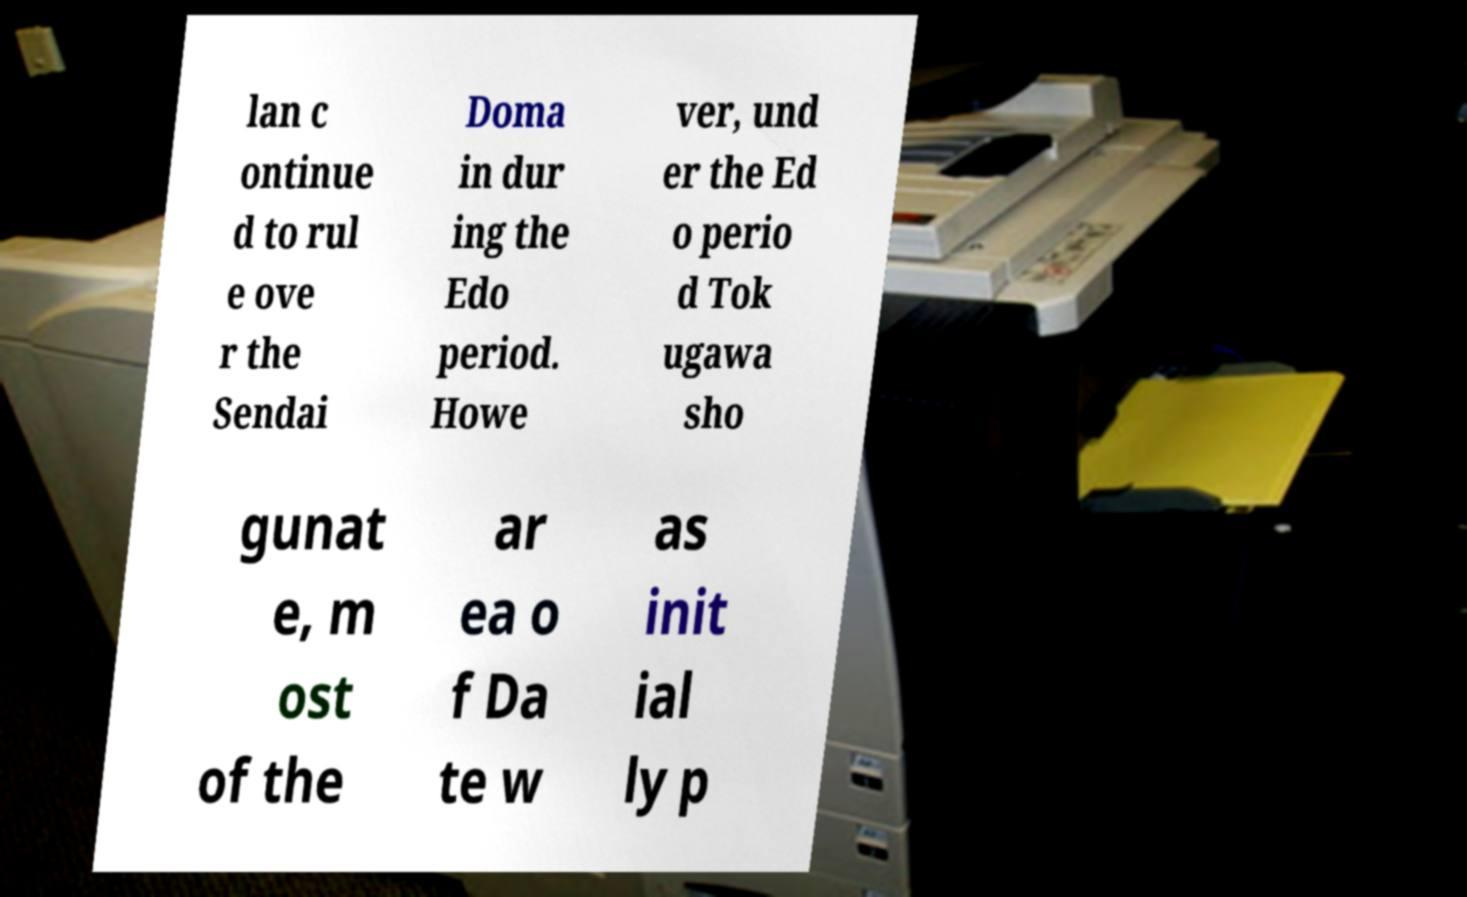There's text embedded in this image that I need extracted. Can you transcribe it verbatim? lan c ontinue d to rul e ove r the Sendai Doma in dur ing the Edo period. Howe ver, und er the Ed o perio d Tok ugawa sho gunat e, m ost of the ar ea o f Da te w as init ial ly p 